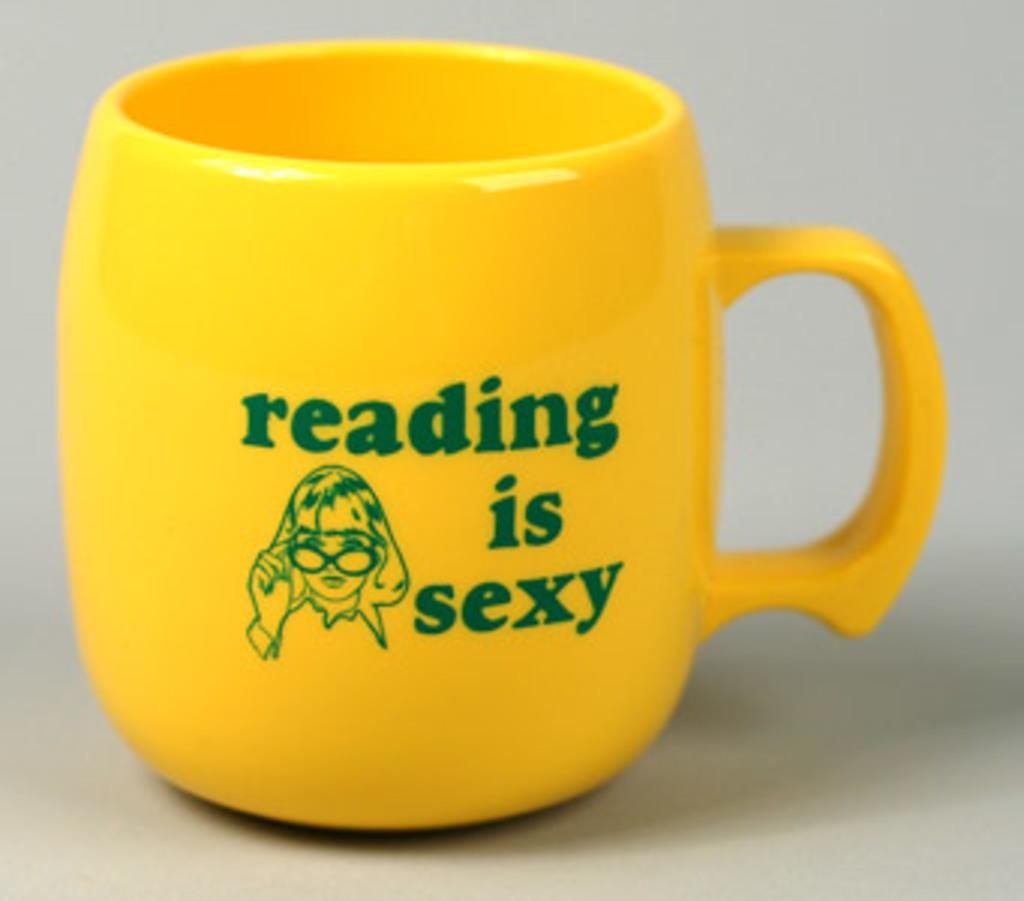<image>
Render a clear and concise summary of the photo. A yellow coffee cup that says reading is sexy 